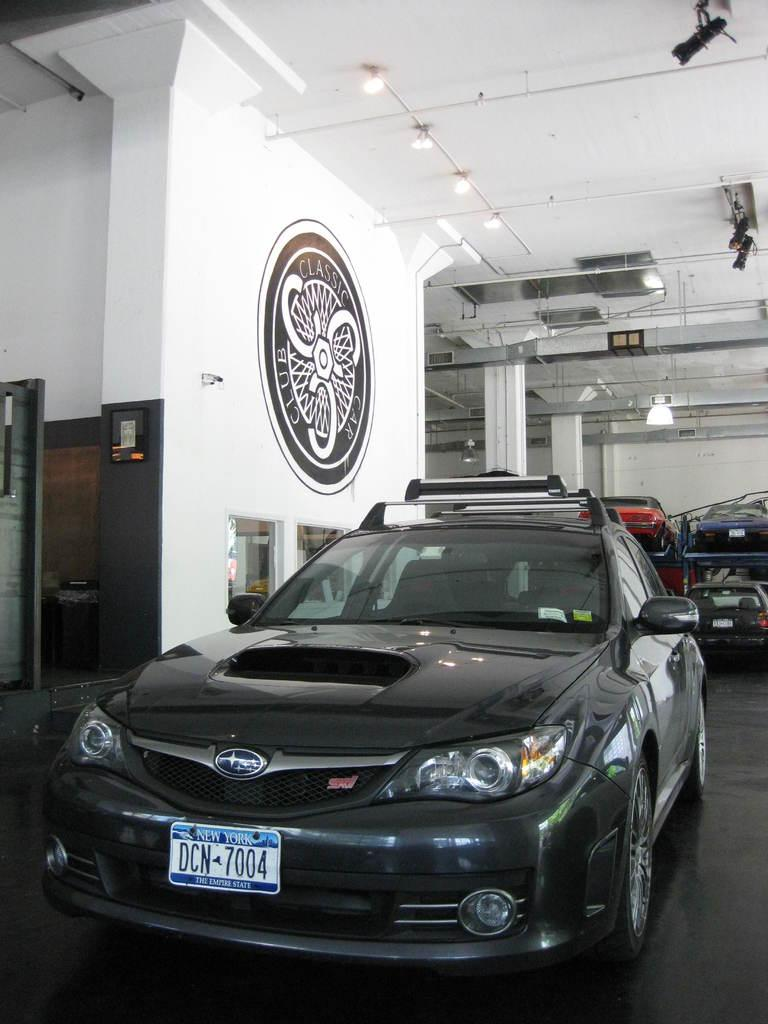What objects are on the floor in the image? There are vehicles on the floor in the image. What can be seen on the left side of the image? There is a wall with a painting on the left side of the image. What is visible at the top of the image? There is a ceiling with lights at the top of the image. How does the painting join the vehicles in the image? The painting and vehicles are separate elements in the image and do not physically join each other. Is there a doll present in the image? No, there is no doll mentioned or visible in the image. 